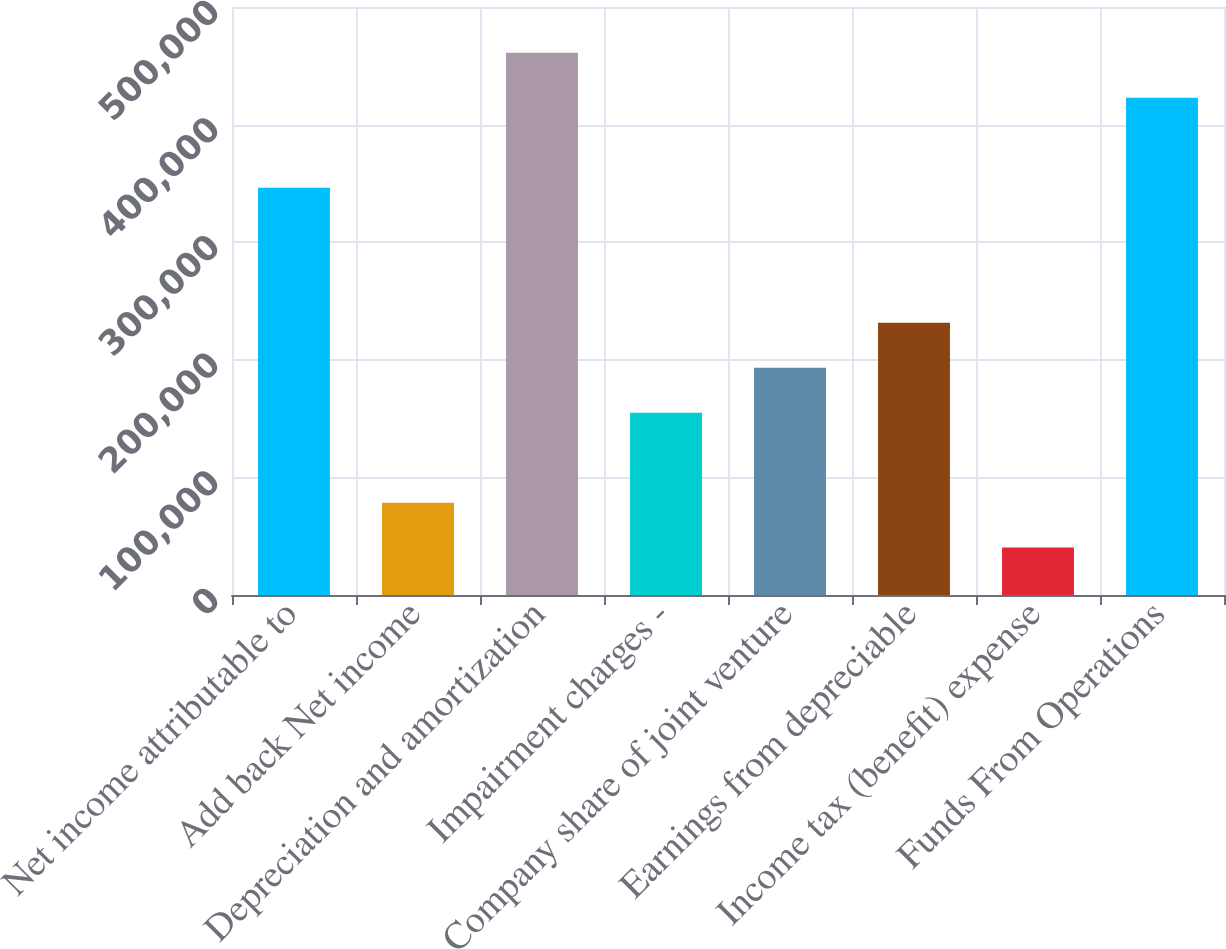Convert chart to OTSL. <chart><loc_0><loc_0><loc_500><loc_500><bar_chart><fcel>Net income attributable to<fcel>Add back Net income<fcel>Depreciation and amortization<fcel>Impairment charges -<fcel>Company share of joint venture<fcel>Earnings from depreciable<fcel>Income tax (benefit) expense<fcel>Funds From Operations<nl><fcel>346358<fcel>78547.4<fcel>461134<fcel>155065<fcel>193324<fcel>231582<fcel>40288.7<fcel>422876<nl></chart> 